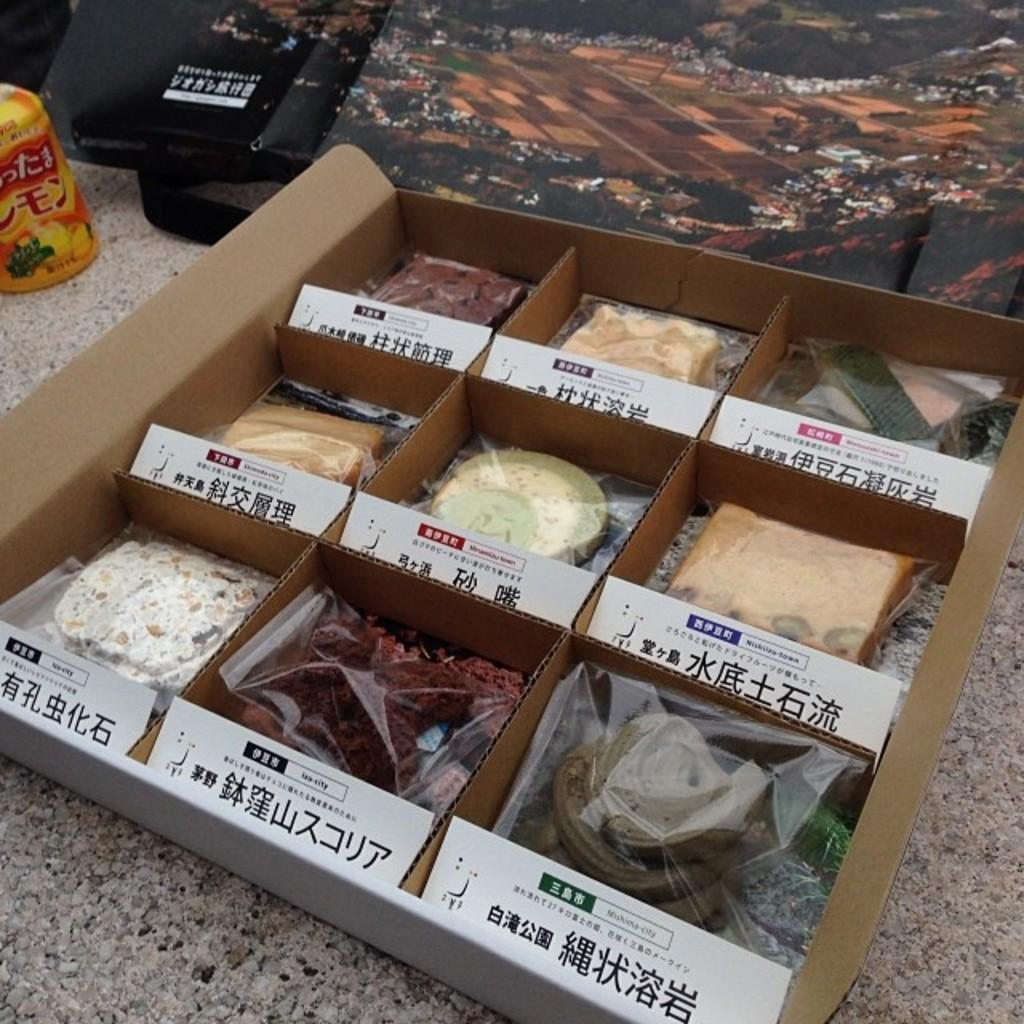What is inside the box that is visible in the image? There is a box with food items in the image. What can be seen on the box besides the food items? There is text on the box. What else is visible on the floor in the image? There are objects on the floor in the image. What type of memory is stored in the box in the image? There is no memory stored in the box in the image; it contains food items. Can you tell me the length of the prose written on the box? There is no prose written on the box in the image; it only has text. 